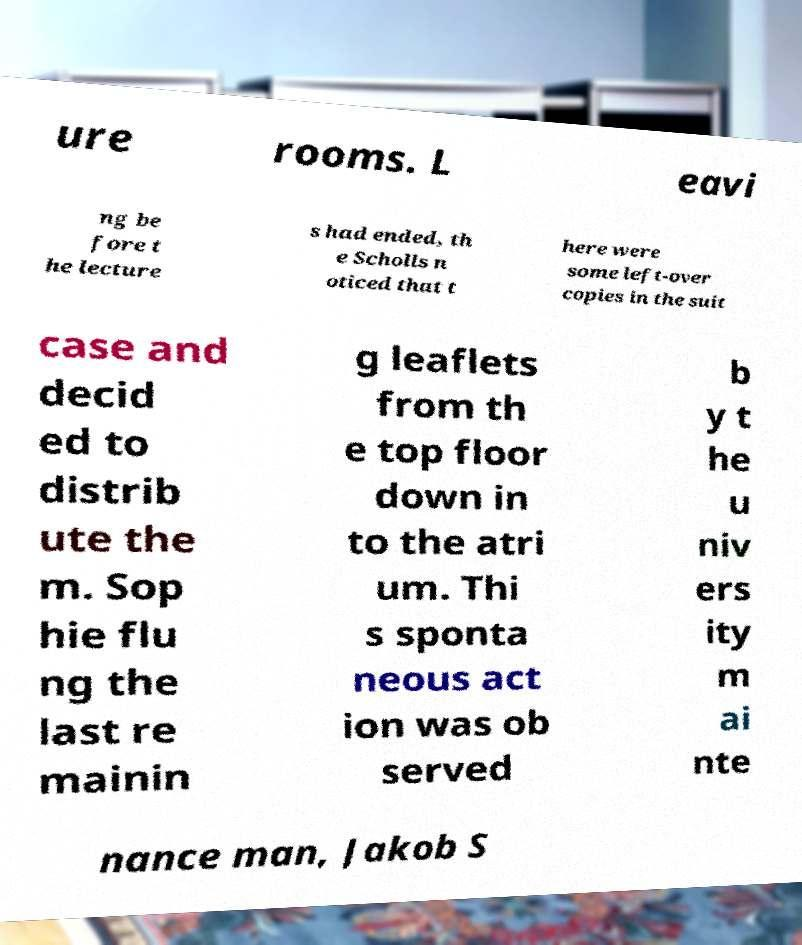Can you accurately transcribe the text from the provided image for me? ure rooms. L eavi ng be fore t he lecture s had ended, th e Scholls n oticed that t here were some left-over copies in the suit case and decid ed to distrib ute the m. Sop hie flu ng the last re mainin g leaflets from th e top floor down in to the atri um. Thi s sponta neous act ion was ob served b y t he u niv ers ity m ai nte nance man, Jakob S 